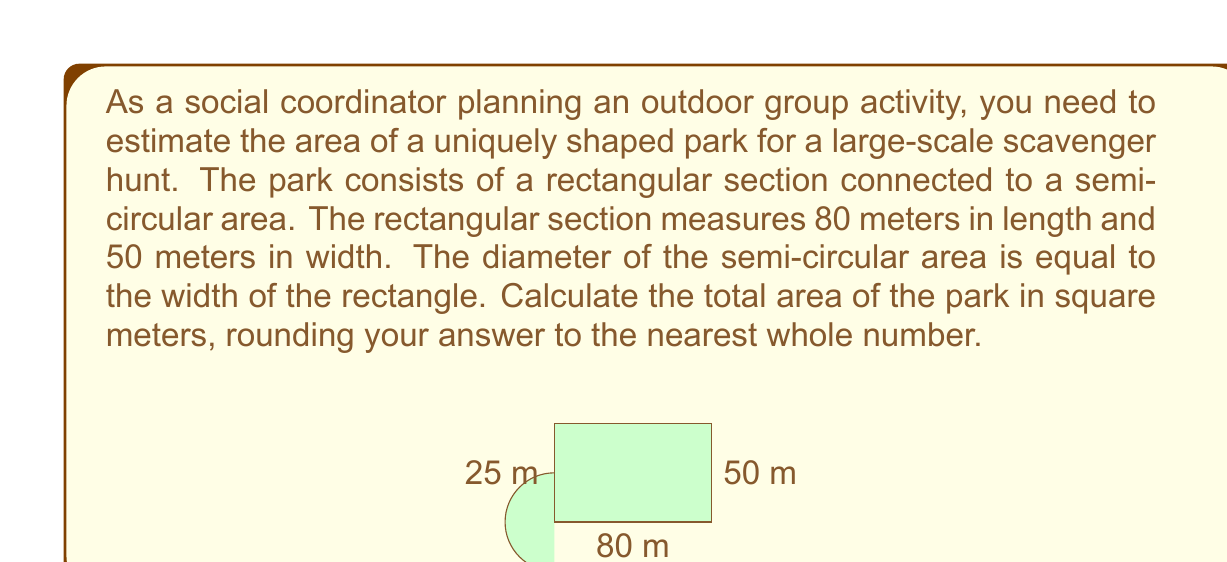Give your solution to this math problem. To solve this problem, we need to calculate the areas of the rectangular section and the semi-circular section separately, then add them together.

1. Area of the rectangular section:
   $$A_{rectangle} = length \times width = 80 \times 50 = 4000 \text{ m}^2$$

2. Area of the semi-circular section:
   The diameter of the semi-circle is equal to the width of the rectangle, which is 50 m.
   Therefore, the radius is half of this, 25 m.
   
   The formula for the area of a circle is $A = \pi r^2$, so for a semi-circle, we use half of this:
   $$A_{semi-circle} = \frac{1}{2} \pi r^2 = \frac{1}{2} \times \pi \times 25^2 \approx 981.75 \text{ m}^2$$

3. Total area of the park:
   $$A_{total} = A_{rectangle} + A_{semi-circle} = 4000 + 981.75 = 4981.75 \text{ m}^2$$

4. Rounding to the nearest whole number:
   $$A_{total} \approx 4982 \text{ m}^2$$
Answer: The total area of the park is approximately 4982 square meters. 